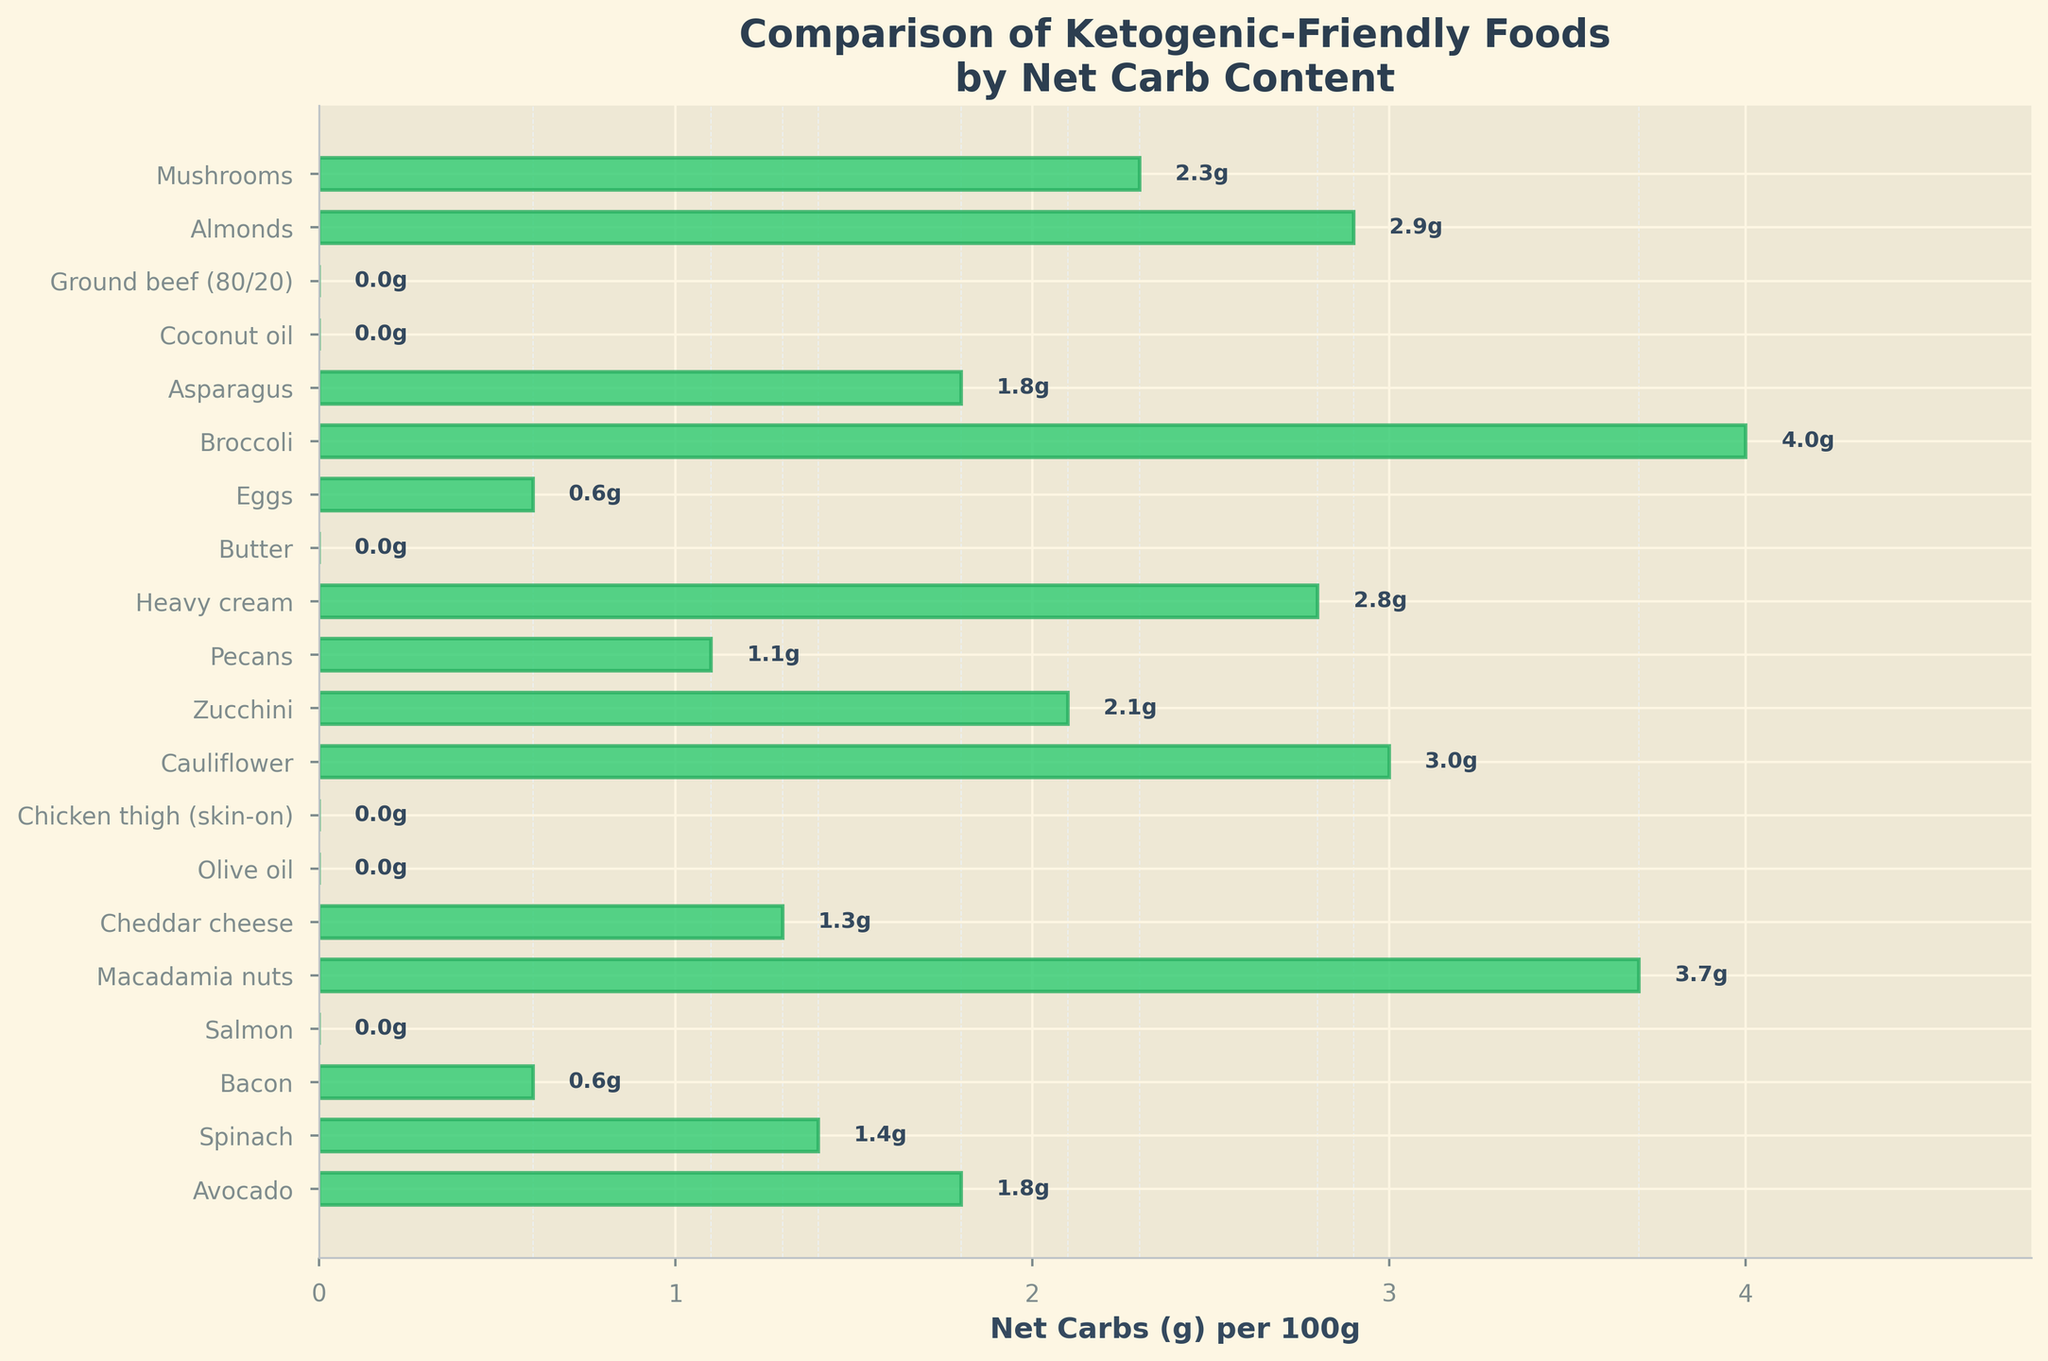What are the top 3 foods with the lowest net carbs per 100g serving? From the bar chart, the lowest net carbs per 100g servings can be identified by the shortest bars. The top 3 foods are Salmon, Olive Oil, and Chicken Thigh (skin-on), all with 0g net carbs.
Answer: Salmon, Olive Oil, Chicken Thigh (skin-on) Which food has the highest net carbs per 100g serving? The bar chart shows that Broccoli has the longest bar, representing the highest net carb content of 4g per 100g serving.
Answer: Broccoli What is the average net carb content of Avocado, Bacon, and Almonds? Avocado has 1.8g, Bacon has 0.6g, and Almonds have 2.9g net carbs per 100g. The sum is 1.8 + 0.6 + 2.9 = 5.3g. Averaging them: 5.3/3 ≈ 1.77g.
Answer: 1.77g By how much does the net carb content of Cauliflower exceed that of Pecans? Cauliflower has 3g net carbs per 100g and Pecans have 1.1g. The difference is 3 - 1.1 = 1.9g.
Answer: 1.9g Which two foods have the same net carb content per 100g serving? By reviewing the bar lengths, Avocado and Asparagus both have bars of the same length, indicating 1.8g net carbs per 100g serving.
Answer: Avocado and Asparagus Are there more foods with 0g net carbs or more than 2g net carbs per 100g serving? Foods with 0g net carbs: Salmon, Olive Oil, Chicken Thigh, Butter, Coconut oil, Ground beef (6 items). Foods with more than 2g net carbs: Macadamia nuts, Cauliflower, Zucchini, Heavy cream, Almonds, Mushrooms, Broccoli (7 items). There are more foods with more than 2g net carbs.
Answer: More foods with more than 2g What is the range of net carb content among the foods listed? The range is the difference between the highest and lowest values. The highest net carb content is Broccoli with 4g, and the lowest is several items with 0g. Therefore, the range is 4 - 0 = 4g.
Answer: 4g Which food has a net carb content closest to 1g per 100g serving? By examining the bar lengths, Cheddar cheese has a net carb content close to 1g, specifically 1.3g per 100g serving.
Answer: Cheddar cheese How much more net carbs does Heavy cream have compared to Zucchini? Heavy cream has 2.8g, and Zucchini has 2.1g per 100g serving. The difference is 2.8 - 2.1 = 0.7g.
Answer: 0.7g 